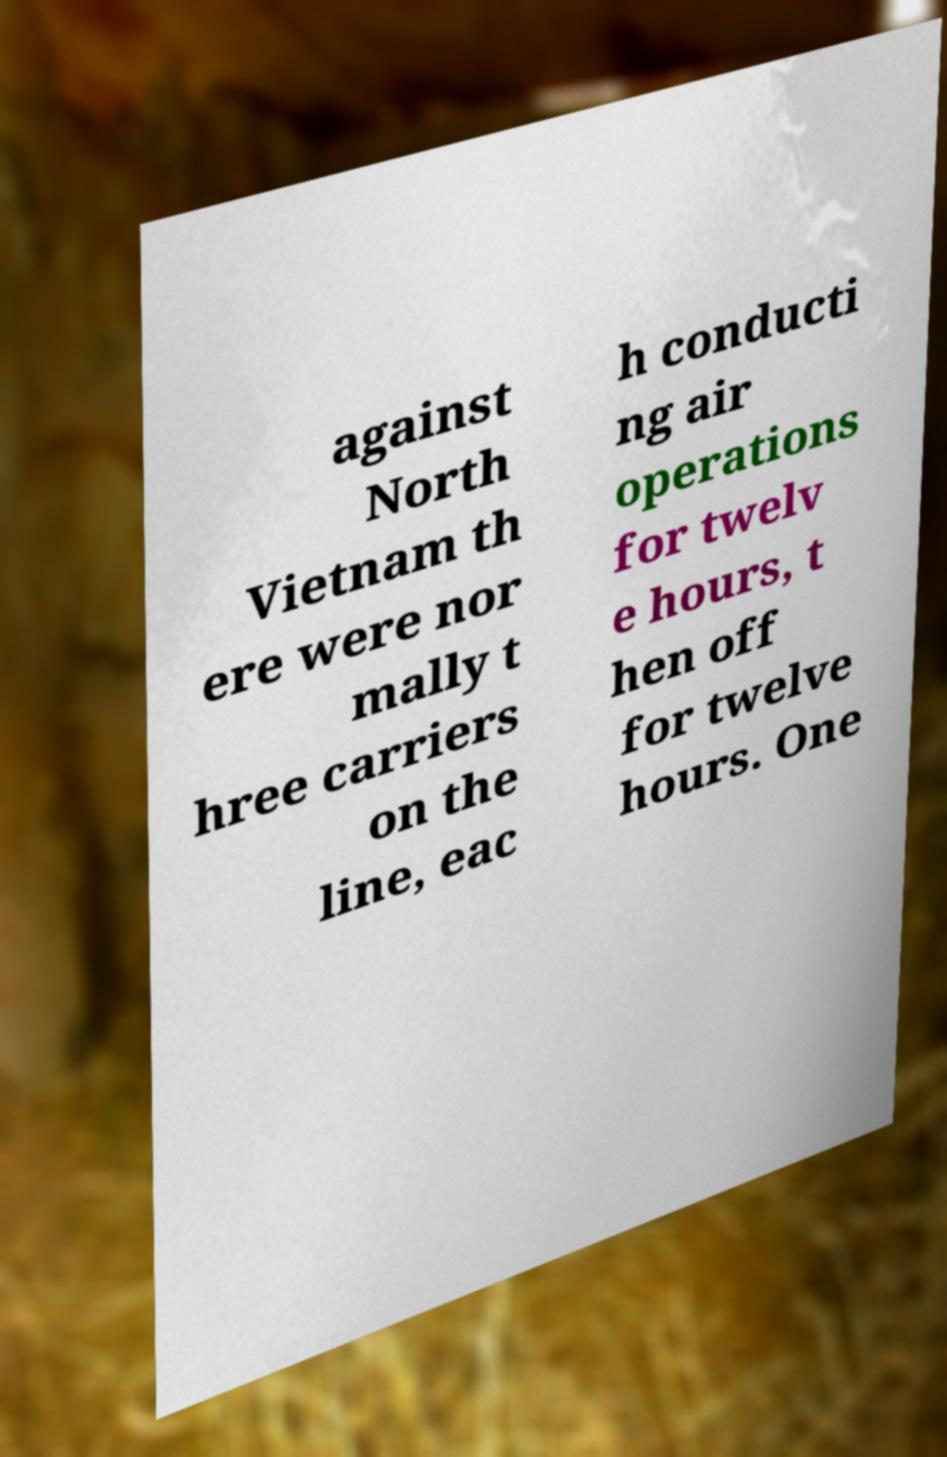For documentation purposes, I need the text within this image transcribed. Could you provide that? against North Vietnam th ere were nor mally t hree carriers on the line, eac h conducti ng air operations for twelv e hours, t hen off for twelve hours. One 